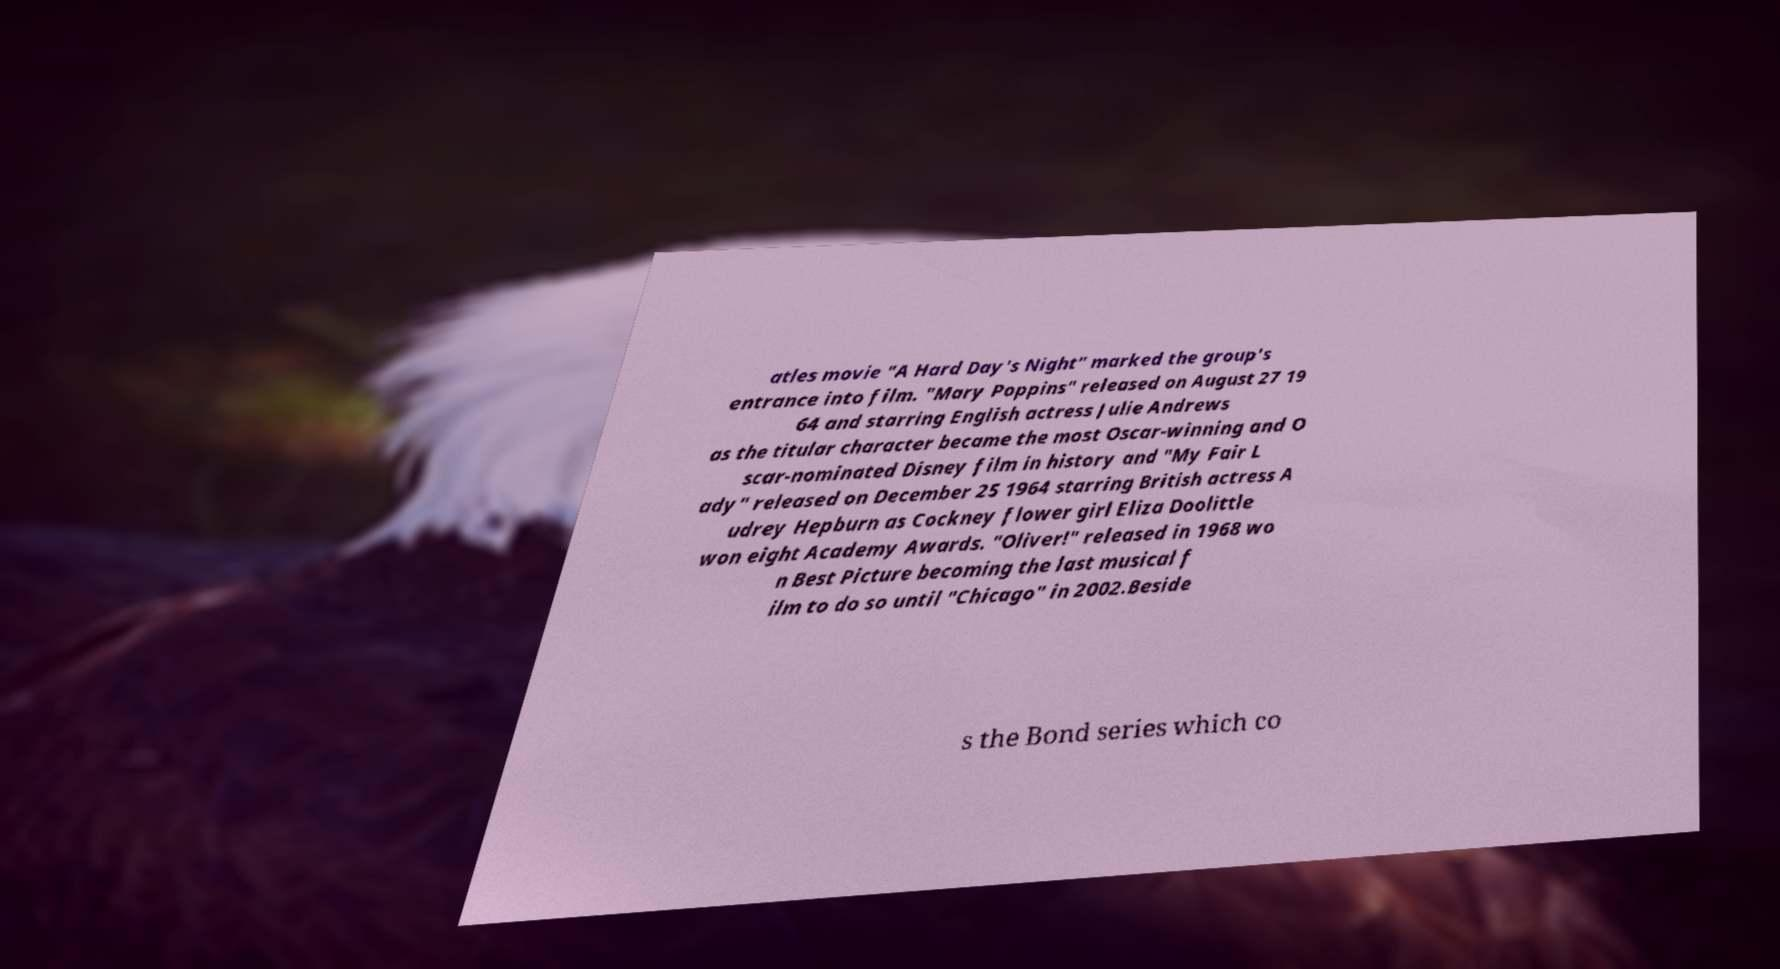For documentation purposes, I need the text within this image transcribed. Could you provide that? atles movie "A Hard Day's Night" marked the group's entrance into film. "Mary Poppins" released on August 27 19 64 and starring English actress Julie Andrews as the titular character became the most Oscar-winning and O scar-nominated Disney film in history and "My Fair L ady" released on December 25 1964 starring British actress A udrey Hepburn as Cockney flower girl Eliza Doolittle won eight Academy Awards. "Oliver!" released in 1968 wo n Best Picture becoming the last musical f ilm to do so until "Chicago" in 2002.Beside s the Bond series which co 